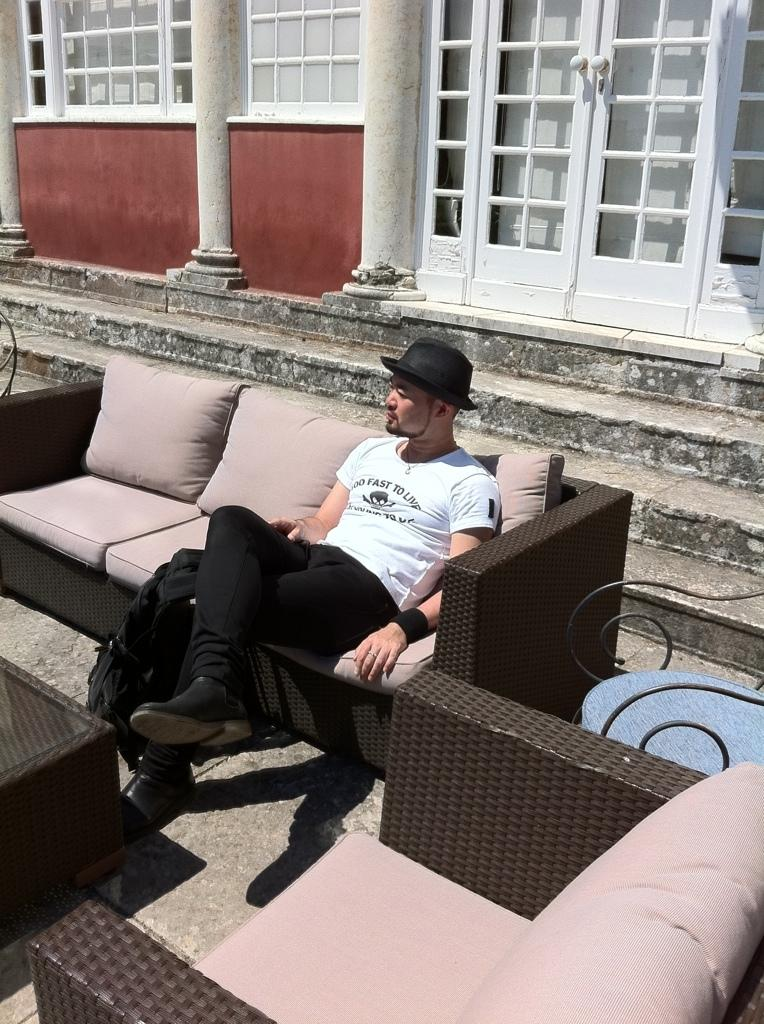What is the man in the image doing? The man is seated on the sofa in the image. What is in front of the man? There is a table in front of the man. Are there any other furniture pieces visible in the image? Yes, there are chairs visible in the image. What type of event is taking place in the image involving a baseball and a wren? There is no baseball or wren present in the image, so no such event is taking place. 